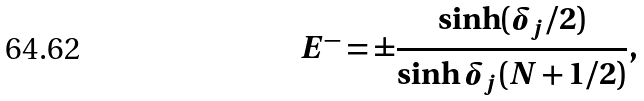Convert formula to latex. <formula><loc_0><loc_0><loc_500><loc_500>E ^ { - } = \pm \frac { \sinh ( \delta _ { j } / 2 ) } { \sinh \delta _ { j } ( N + 1 / 2 ) } ,</formula> 